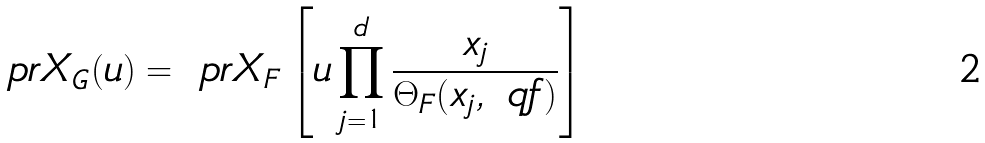<formula> <loc_0><loc_0><loc_500><loc_500>\ p r { X } _ { G } ( u ) = \ p r { X } _ { F } \left [ u \prod _ { j = 1 } ^ { d } \frac { x _ { j } } { \Theta _ { F } ( x _ { j } , \ q f ) } \right ]</formula> 